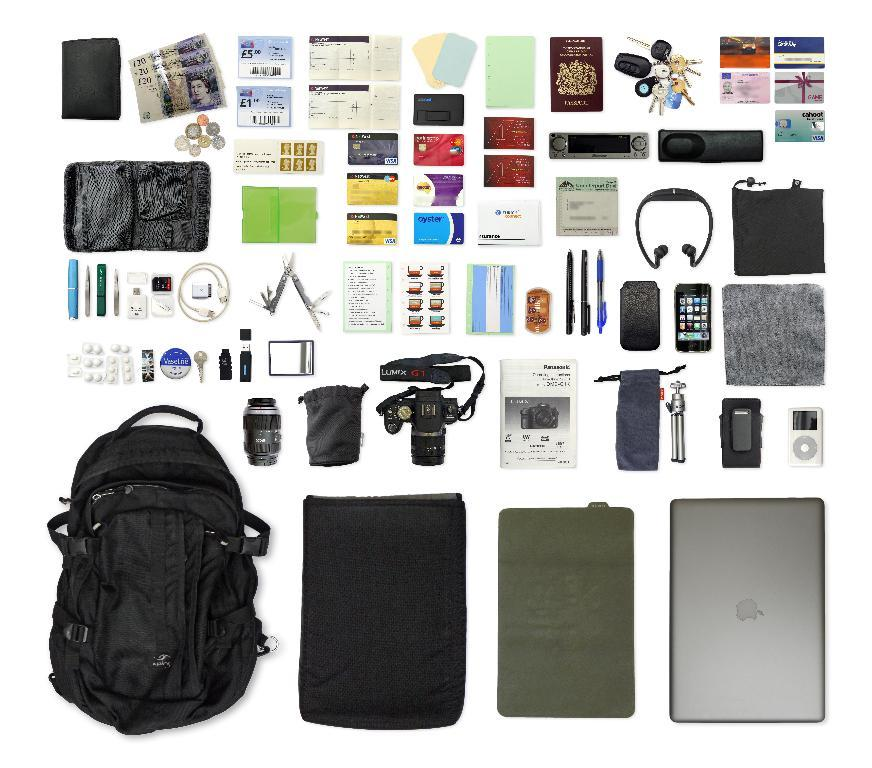What electronic device is located at the bottom of the image? There is a laptop at the bottom of the image. What other item is located at the bottom of the image? There is a bag at the bottom of the image. What objects are in the middle of the image? There is a mobile, a camera, a book, pens, and paper in the middle of the image. What items are at the top of the image? There is money, a wallet, a book, keys, and cards at the top of the image. What type of instrument can be seen playing in the image? There is no instrument present in the image; it features a laptop, a bag, a mobile, a camera, a book, pens, paper, money, a wallet, a book, keys, and cards. Can you describe the clouds in the image? There are no clouds present in the image. 